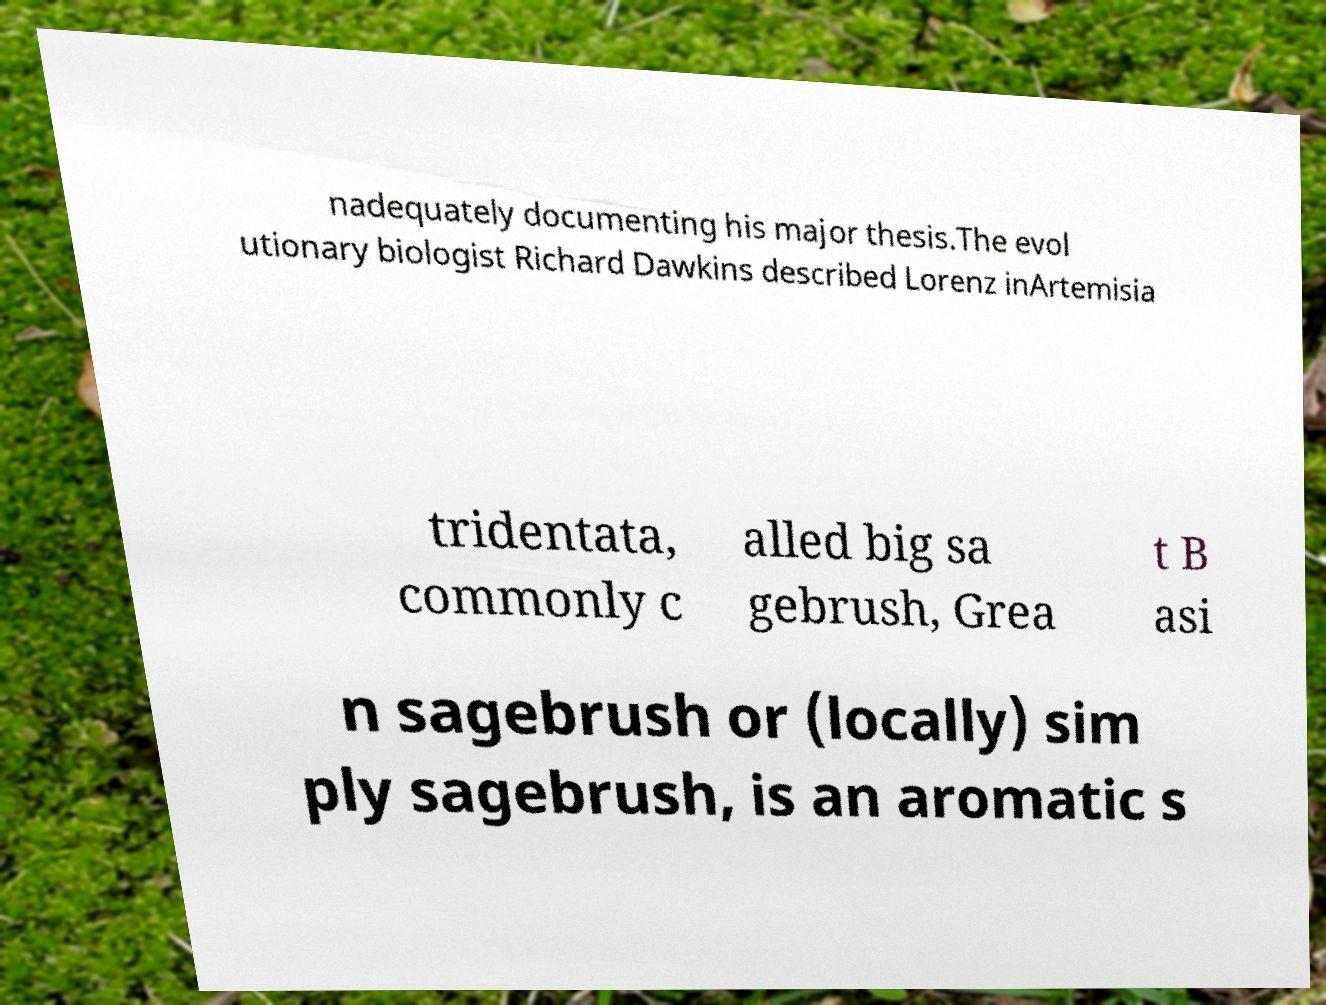Can you accurately transcribe the text from the provided image for me? nadequately documenting his major thesis.The evol utionary biologist Richard Dawkins described Lorenz inArtemisia tridentata, commonly c alled big sa gebrush, Grea t B asi n sagebrush or (locally) sim ply sagebrush, is an aromatic s 